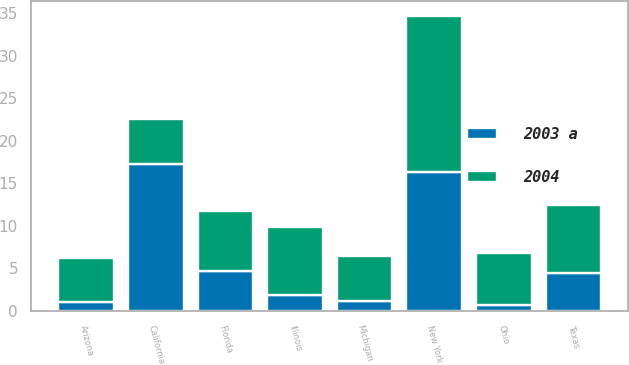Convert chart. <chart><loc_0><loc_0><loc_500><loc_500><stacked_bar_chart><ecel><fcel>California<fcel>New York<fcel>Illinois<fcel>Texas<fcel>Florida<fcel>Ohio<fcel>Arizona<fcel>Michigan<nl><fcel>2004<fcel>5.2<fcel>18.4<fcel>8<fcel>7.9<fcel>7.1<fcel>6.1<fcel>5.2<fcel>5.2<nl><fcel>2003 a<fcel>17.3<fcel>16.3<fcel>1.9<fcel>4.5<fcel>4.7<fcel>0.7<fcel>1<fcel>1.2<nl></chart> 